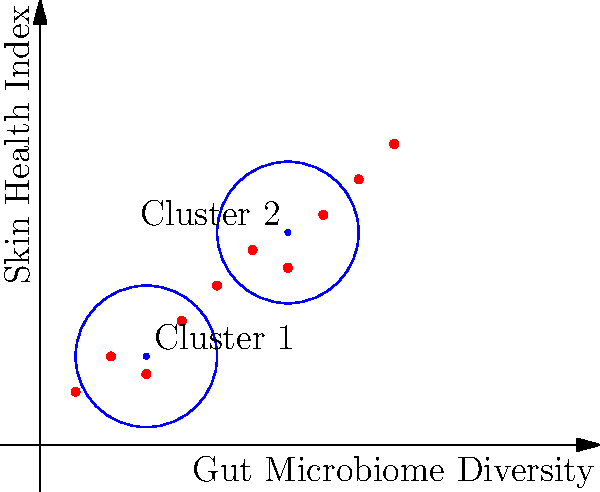Based on the scatter plot showing the relationship between gut microbiome diversity and skin health index, how many distinct clusters of patients can be identified, and what clustering method is likely being used? To answer this question, we need to analyze the scatter plot and identify the key features:

1. The plot shows data points representing individual patients, with gut microbiome diversity on the x-axis and skin health index on the y-axis.

2. There are two large blue circles on the plot, each centered around a blue dot. These represent cluster centers.

3. The red dots (data points) are distributed in two main groups, roughly corresponding to the areas enclosed by the blue circles.

4. The clustering method used appears to be centroid-based, as evidenced by the clearly marked cluster centers.

5. The circular shape of the clusters suggests that the method is likely k-means clustering, which typically produces circular or spherical clusters.

6. K-means clustering requires the number of clusters to be specified in advance. In this case, there are two distinct clusters visible.

Given these observations, we can conclude that there are two distinct clusters of patients identified in the plot, and the clustering method being used is most likely k-means clustering with $k=2$.
Answer: 2 clusters; k-means clustering 